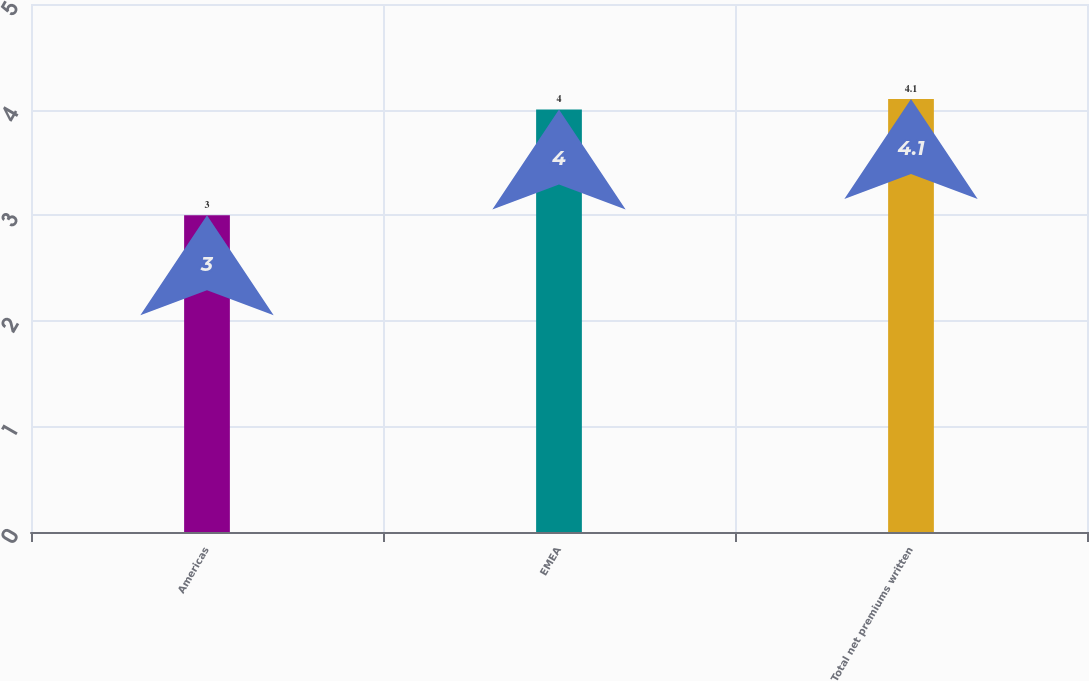Convert chart to OTSL. <chart><loc_0><loc_0><loc_500><loc_500><bar_chart><fcel>Americas<fcel>EMEA<fcel>Total net premiums written<nl><fcel>3<fcel>4<fcel>4.1<nl></chart> 